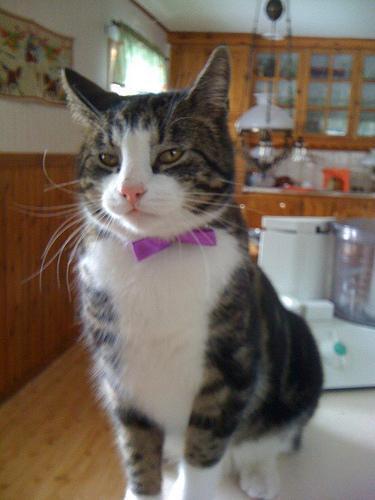How many cats are pictured?
Give a very brief answer. 1. 